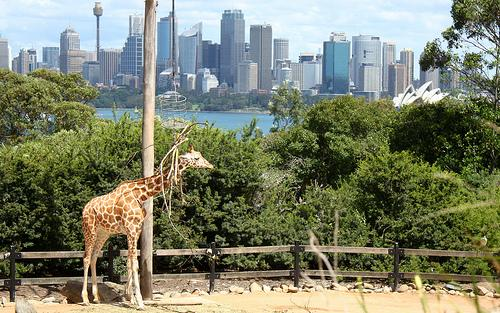Summarize the image in a sentence or two, emphasizing key elements. The image features a yellow and brown giraffe standing near a fenced enclosure with trees, rocks, and the city skyline, including the Sydney Opera House, in the background. Briefly explain what is happening in the image and mention the main subjects. A yellow and brown giraffe is standing close to a fence and trees, with rocks on the ground, while the city skyline, including the Sydney Opera House, is seen in the background. Provide a description of the picture, noting the main elements. The image features a giraffe standing in an enclosure with a wooden and metal fence, surrounded by trees and rocks, with the Sydney Opera House and city skyline in the background. Mention the primary focus of the image and what it is engaged in. A giraffe with a yellow and brown coat is standing near a wooden fence in an enclosure, surrounded by trees and rocks on the ground. Write a short description of the image, focusing on significant components. In the image, a giraffe stands near a fenced area with trees and rocks, and the city skyline, including the Sydney Opera House, is visible in the background. Enumerate the key components in the image and their basic details. 5. Cityscape: including the Sydney Opera House In a concise manner, convey the main idea of the image. A giraffe standing by a fence with trees and cityscape, including the Sydney Opera House, behind it. Provide a brief overview of the image, highlighting important elements. The image shows a giraffe standing by a fenced enclosure with trees, rocks, and sandy ground, while the city skyline and Sydney Opera House are visible in the background. Describe the image in one sentence, focusing on the main features. A giraffe is standing near a wooden fence, with trees, rocks on the ground, and a city skyline including the Sydney Opera House in the background. Give an overview of the main subjects within the image surrounding, and mention their interaction. The giraffe, positioned near a fence and wooden pole in an enclosure, is surrounded by trees, rocks, and sandy ground, while the Sydney Opera House and city skyline can be seen in the background. 